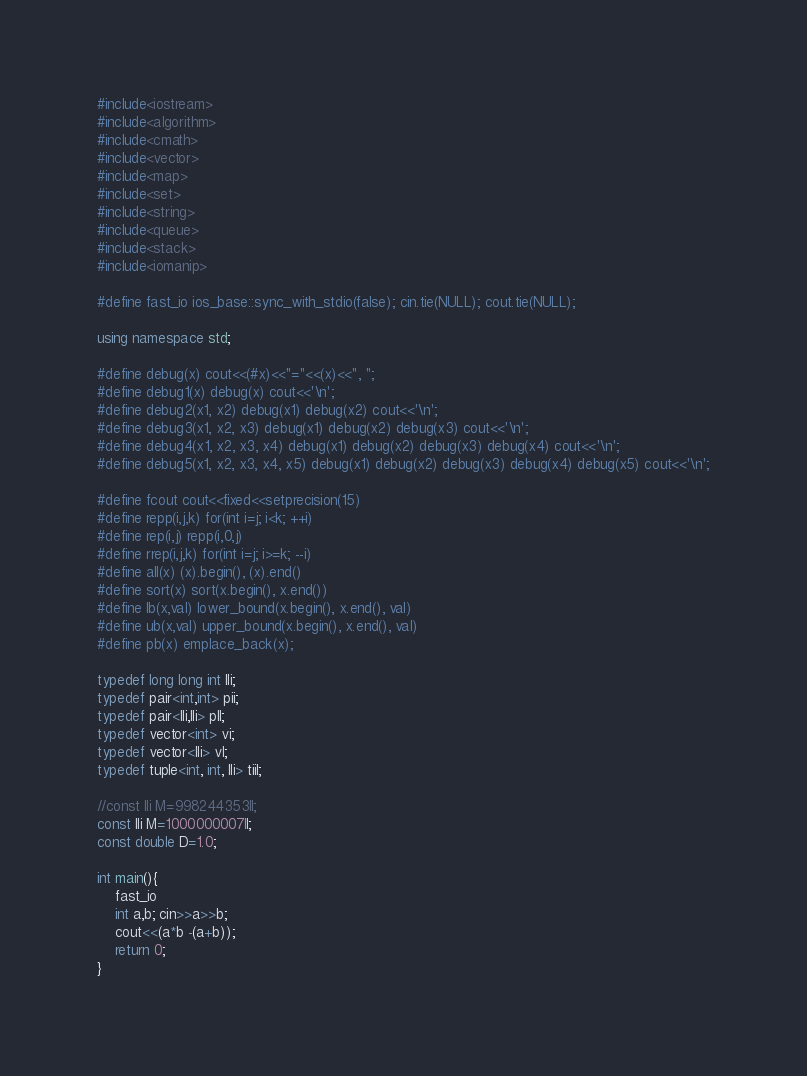<code> <loc_0><loc_0><loc_500><loc_500><_C++_>#include<iostream>
#include<algorithm>
#include<cmath>
#include<vector>
#include<map>
#include<set>
#include<string>
#include<queue>
#include<stack>
#include<iomanip>

#define fast_io ios_base::sync_with_stdio(false); cin.tie(NULL); cout.tie(NULL);

using namespace std;

#define debug(x) cout<<(#x)<<"="<<(x)<<", ";
#define debug1(x) debug(x) cout<<'\n';
#define debug2(x1, x2) debug(x1) debug(x2) cout<<'\n';
#define debug3(x1, x2, x3) debug(x1) debug(x2) debug(x3) cout<<'\n';
#define debug4(x1, x2, x3, x4) debug(x1) debug(x2) debug(x3) debug(x4) cout<<'\n';
#define debug5(x1, x2, x3, x4, x5) debug(x1) debug(x2) debug(x3) debug(x4) debug(x5) cout<<'\n';

#define fcout cout<<fixed<<setprecision(15)
#define repp(i,j,k) for(int i=j; i<k; ++i)
#define rep(i,j) repp(i,0,j)
#define rrep(i,j,k) for(int i=j; i>=k; --i)
#define all(x) (x).begin(), (x).end()
#define sort(x) sort(x.begin(), x.end())
#define lb(x,val) lower_bound(x.begin(), x.end(), val)
#define ub(x,val) upper_bound(x.begin(), x.end(), val)
#define pb(x) emplace_back(x);

typedef long long int lli;
typedef pair<int,int> pii;
typedef pair<lli,lli> pll;
typedef vector<int> vi;
typedef vector<lli> vl;
typedef tuple<int, int, lli> tiil;

//const lli M=998244353ll;
const lli M=1000000007ll;
const double D=1.0;

int main(){
	fast_io
	int a,b; cin>>a>>b;
	cout<<(a*b -(a+b));
	return 0;
}</code> 